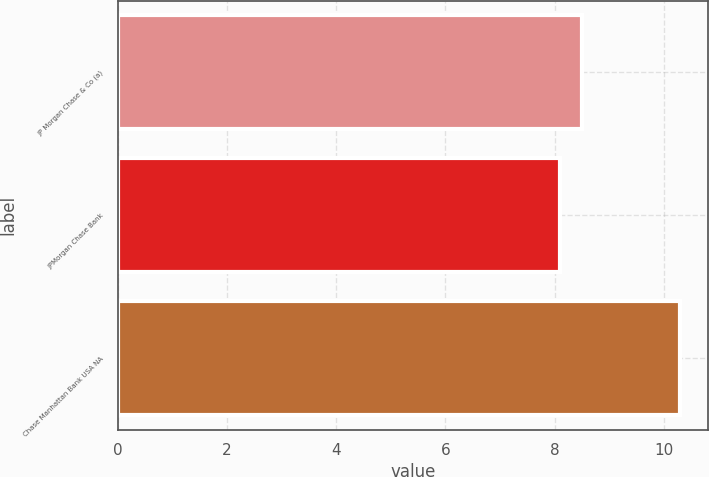Convert chart to OTSL. <chart><loc_0><loc_0><loc_500><loc_500><bar_chart><fcel>JP Morgan Chase & Co (a)<fcel>JPMorgan Chase Bank<fcel>Chase Manhattan Bank USA NA<nl><fcel>8.5<fcel>8.1<fcel>10.3<nl></chart> 